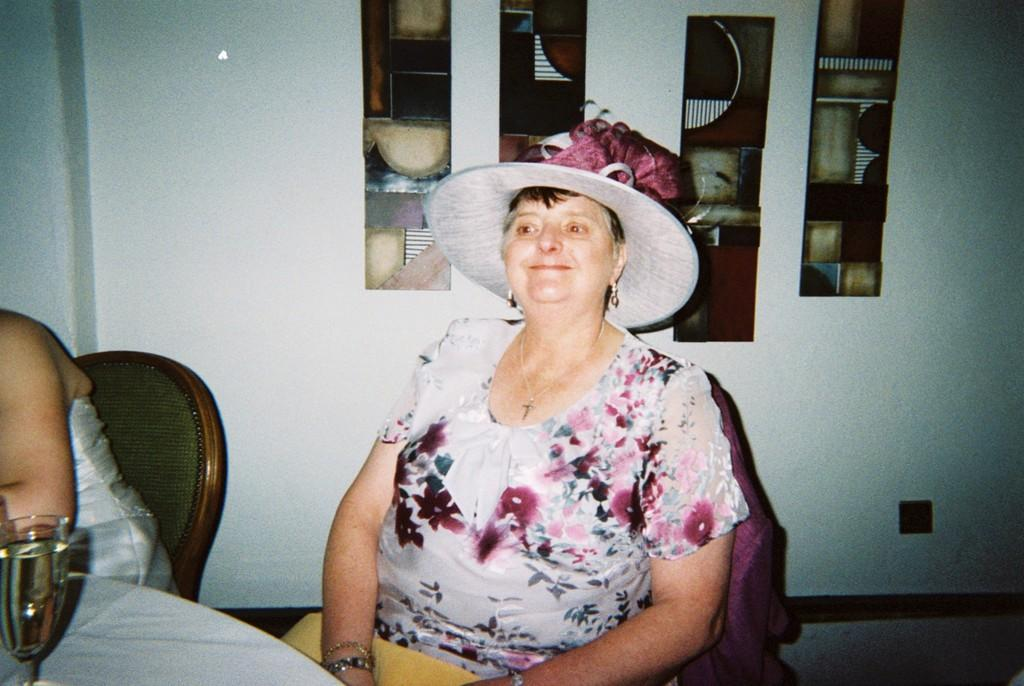How many people are in the image? There are two women in the image. What are the women doing in the image? The women are sitting on chairs. What can be seen on the table in the image? There is a glass on a table. What is visible in the background of the image? There are objects on the wall in the background. How many rabbits are hopping on the table in the image? There are no rabbits visible in the image. 